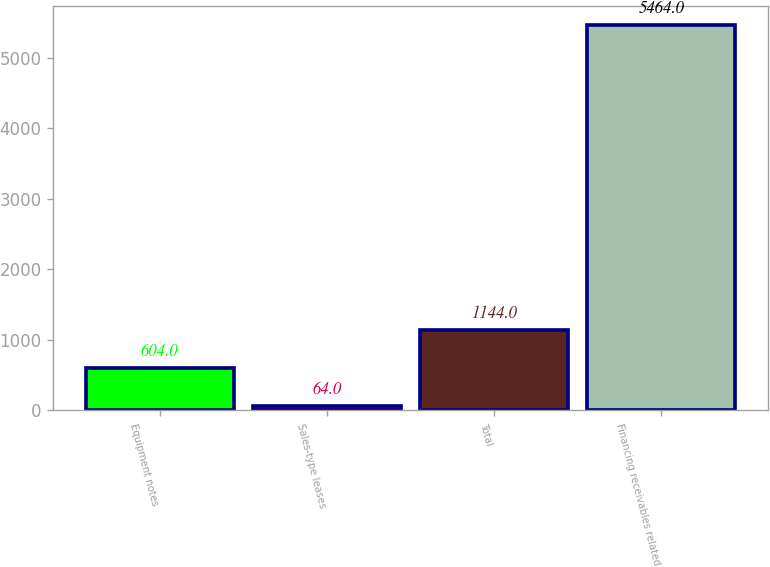<chart> <loc_0><loc_0><loc_500><loc_500><bar_chart><fcel>Equipment notes<fcel>Sales-type leases<fcel>Total<fcel>Financing receivables related<nl><fcel>604<fcel>64<fcel>1144<fcel>5464<nl></chart> 